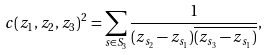Convert formula to latex. <formula><loc_0><loc_0><loc_500><loc_500>c ( z _ { 1 } , z _ { 2 } , z _ { 3 } ) ^ { 2 } = \sum _ { s \in S _ { 3 } } \frac { 1 } { ( z _ { s _ { 2 } } - z _ { s _ { 1 } } ) \overline { ( z _ { s _ { 3 } } - z _ { s _ { 1 } } ) } } ,</formula> 